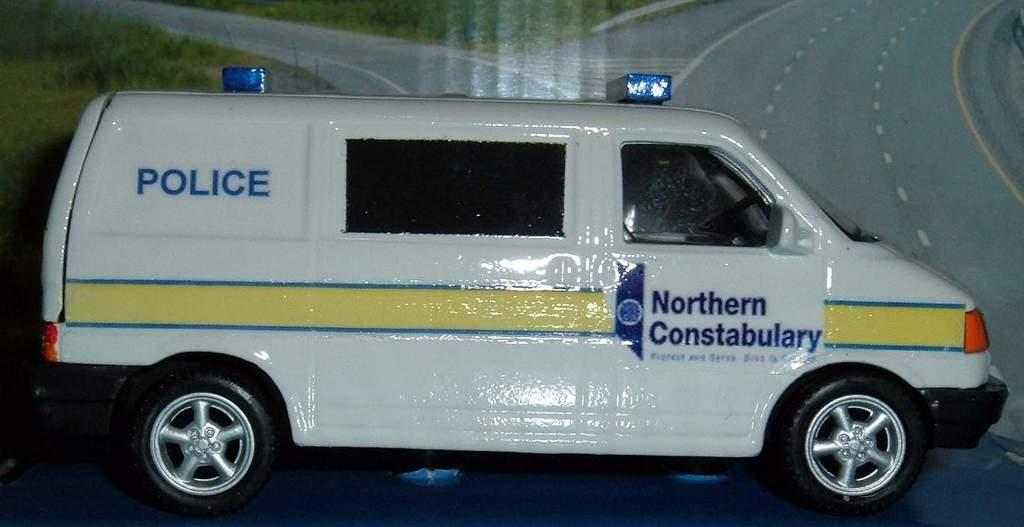Provide a one-sentence caption for the provided image. A police van has the words Northern Constabulary on the door. 